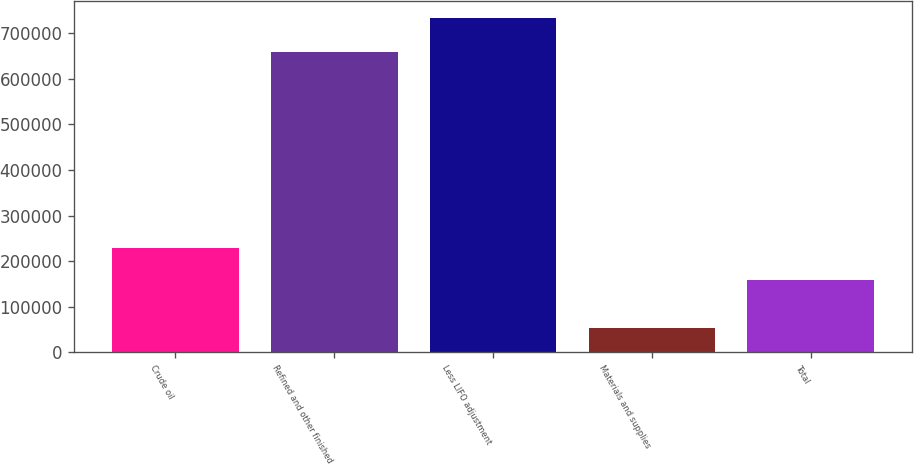<chart> <loc_0><loc_0><loc_500><loc_500><bar_chart><fcel>Crude oil<fcel>Refined and other finished<fcel>Less LIFO adjustment<fcel>Materials and supplies<fcel>Total<nl><fcel>227760<fcel>657914<fcel>734177<fcel>52512<fcel>159594<nl></chart> 